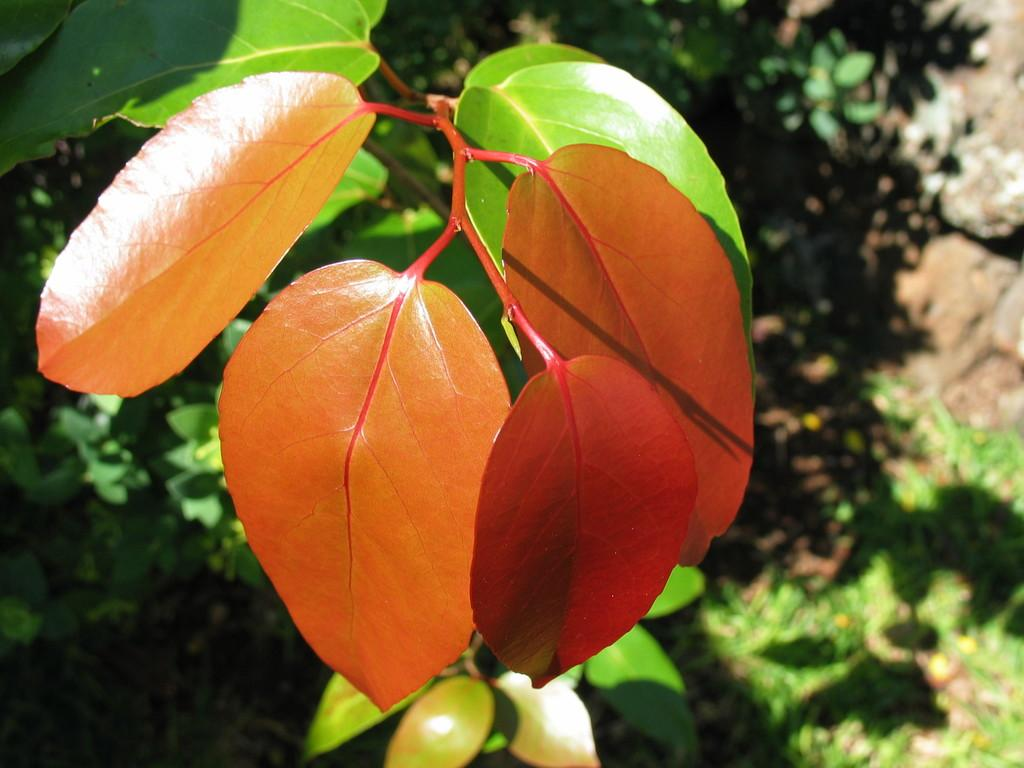What colors can be seen in the leaves in the image? There are green and orange color leaves in the image. What can be observed in addition to the leaves in the image? There is a shadow visible in the image, as well as rocks. What type of bell can be heard ringing in the image? There is no bell present in the image, so it cannot be heard ringing. 